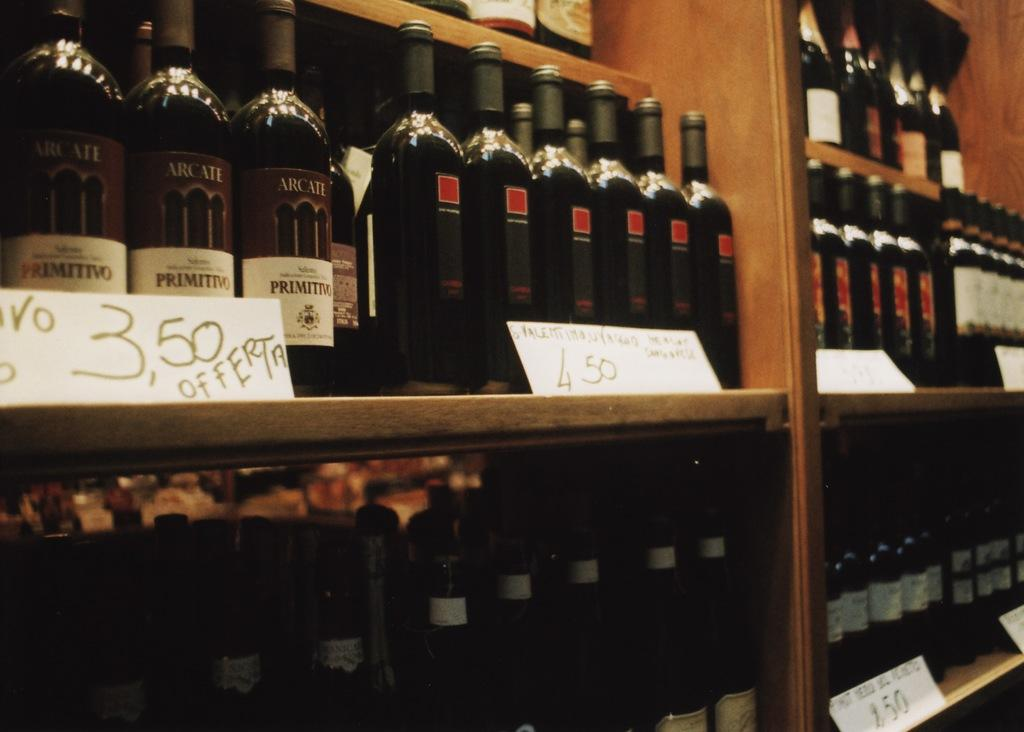<image>
Render a clear and concise summary of the photo. A selection of wines shows that one could buy the Arcate for 3.50. 